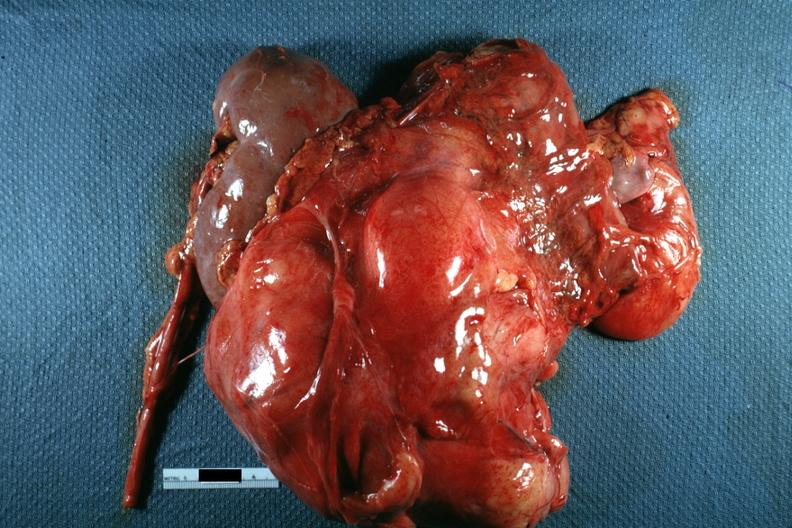what seen on one side photo of little use without showing cut surface?
Answer the question using a single word or phrase. Nodular mass with kidney 